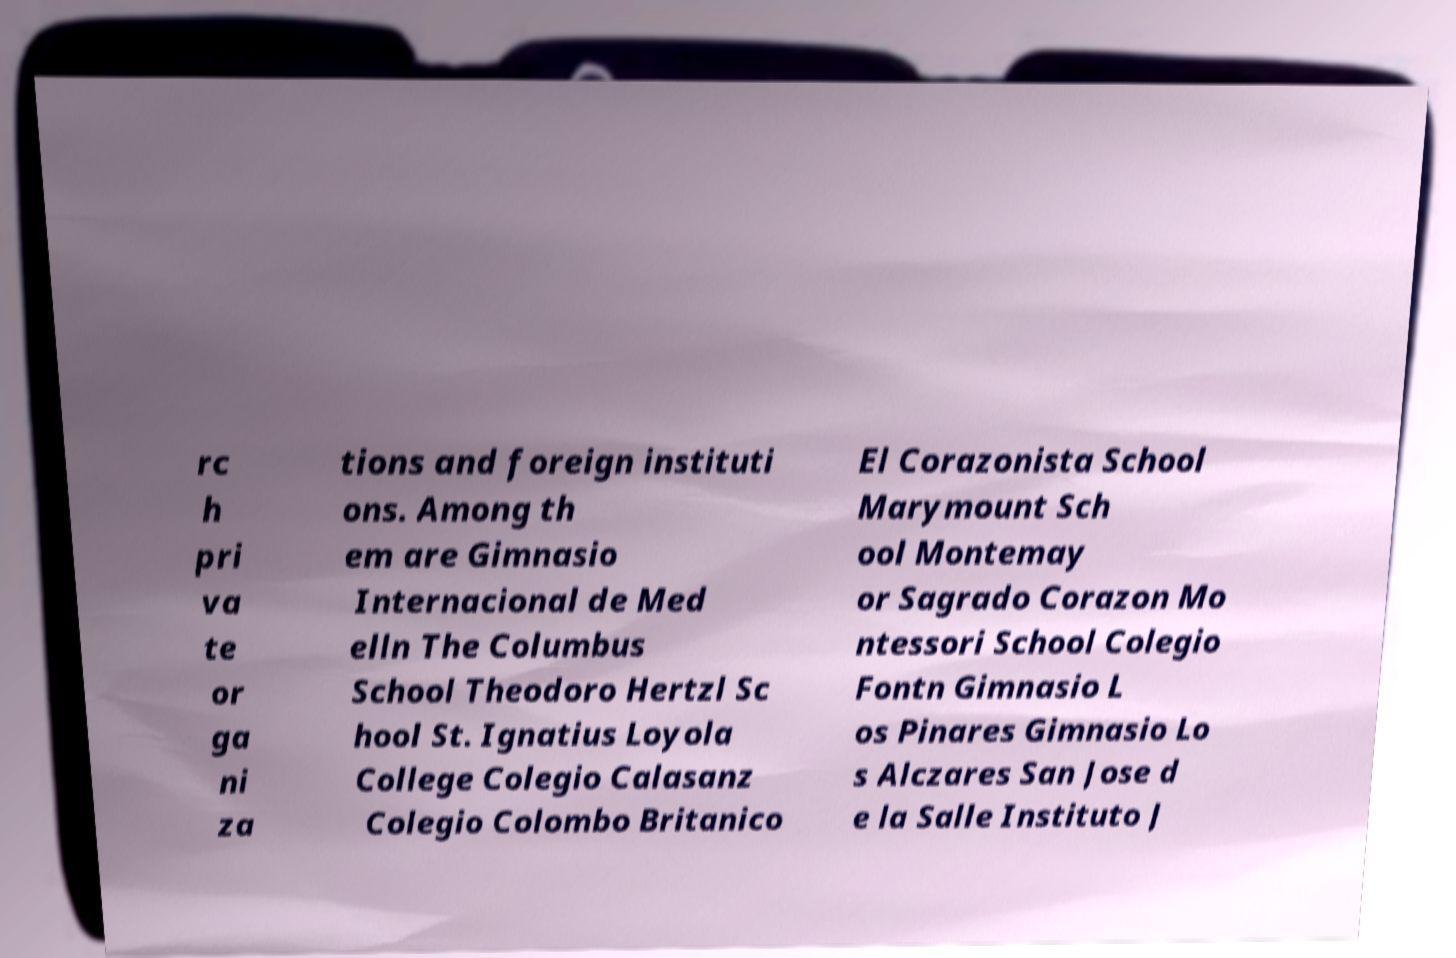Please read and relay the text visible in this image. What does it say? rc h pri va te or ga ni za tions and foreign instituti ons. Among th em are Gimnasio Internacional de Med elln The Columbus School Theodoro Hertzl Sc hool St. Ignatius Loyola College Colegio Calasanz Colegio Colombo Britanico El Corazonista School Marymount Sch ool Montemay or Sagrado Corazon Mo ntessori School Colegio Fontn Gimnasio L os Pinares Gimnasio Lo s Alczares San Jose d e la Salle Instituto J 